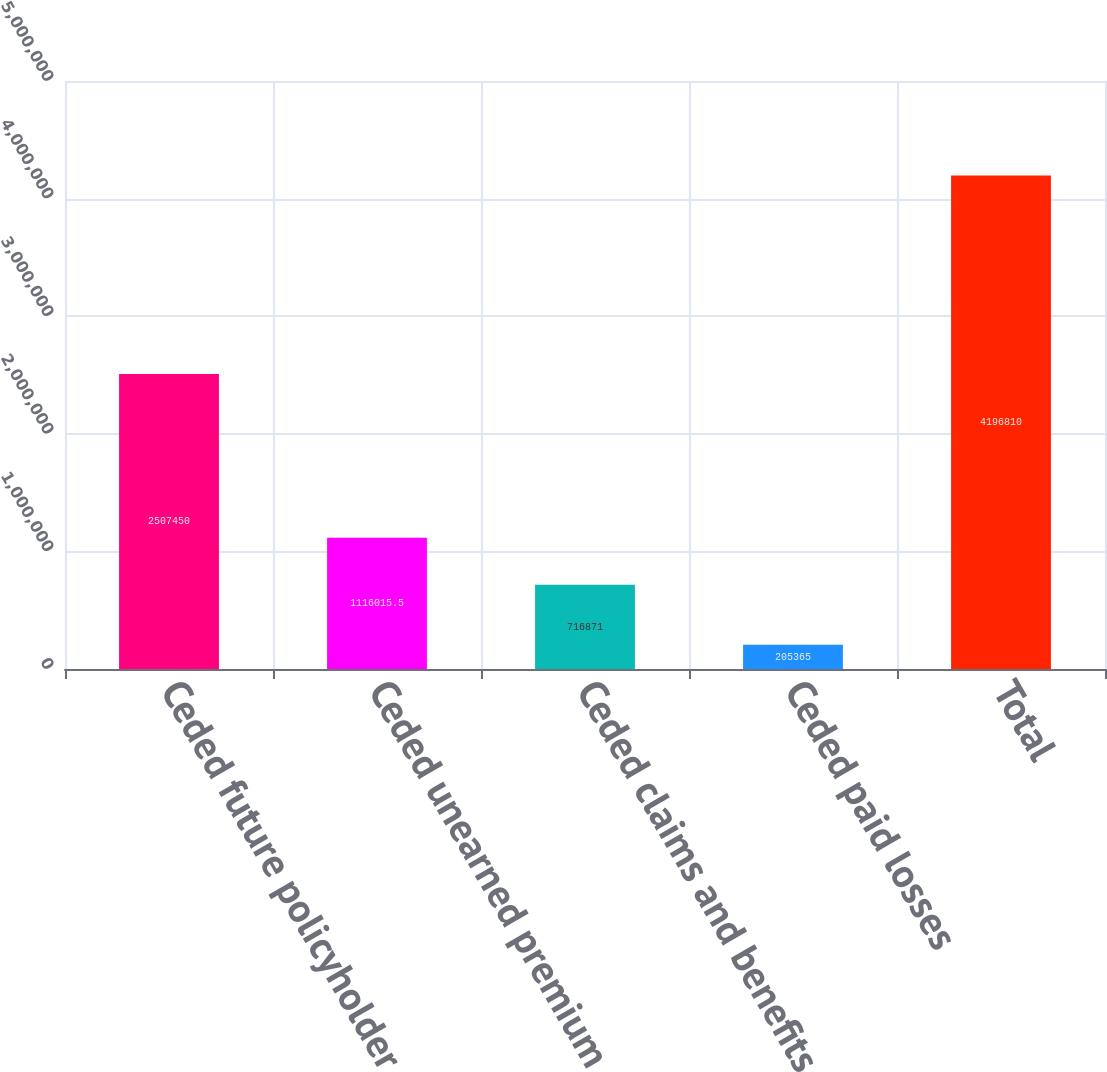<chart> <loc_0><loc_0><loc_500><loc_500><bar_chart><fcel>Ceded future policyholder<fcel>Ceded unearned premium<fcel>Ceded claims and benefits<fcel>Ceded paid losses<fcel>Total<nl><fcel>2.50745e+06<fcel>1.11602e+06<fcel>716871<fcel>205365<fcel>4.19681e+06<nl></chart> 